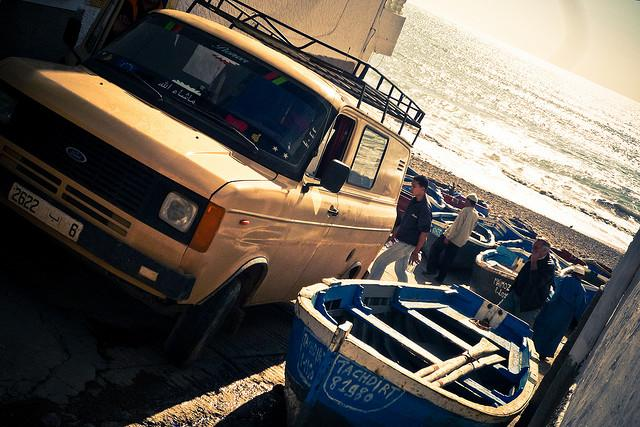What are the first two numbers on the truck? Please explain your reasoning. 26. The numbers in option a match the two numbers on the truck's license plate. 